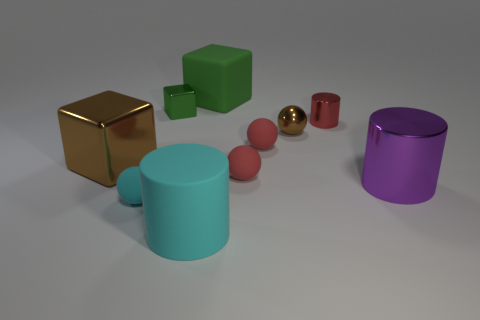Subtract all big cylinders. How many cylinders are left? 1 Subtract all cyan balls. How many balls are left? 3 Subtract 3 spheres. How many spheres are left? 1 Subtract all cubes. How many objects are left? 7 Subtract all green cylinders. How many green cubes are left? 2 Subtract all big matte cubes. Subtract all small balls. How many objects are left? 5 Add 2 metallic objects. How many metallic objects are left? 7 Add 4 small metal objects. How many small metal objects exist? 7 Subtract 0 purple cubes. How many objects are left? 10 Subtract all blue cylinders. Subtract all red spheres. How many cylinders are left? 3 